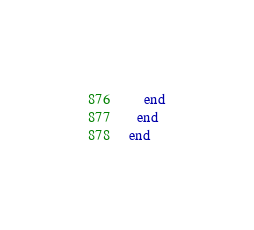<code> <loc_0><loc_0><loc_500><loc_500><_Ruby_>    end
  end
end
</code> 